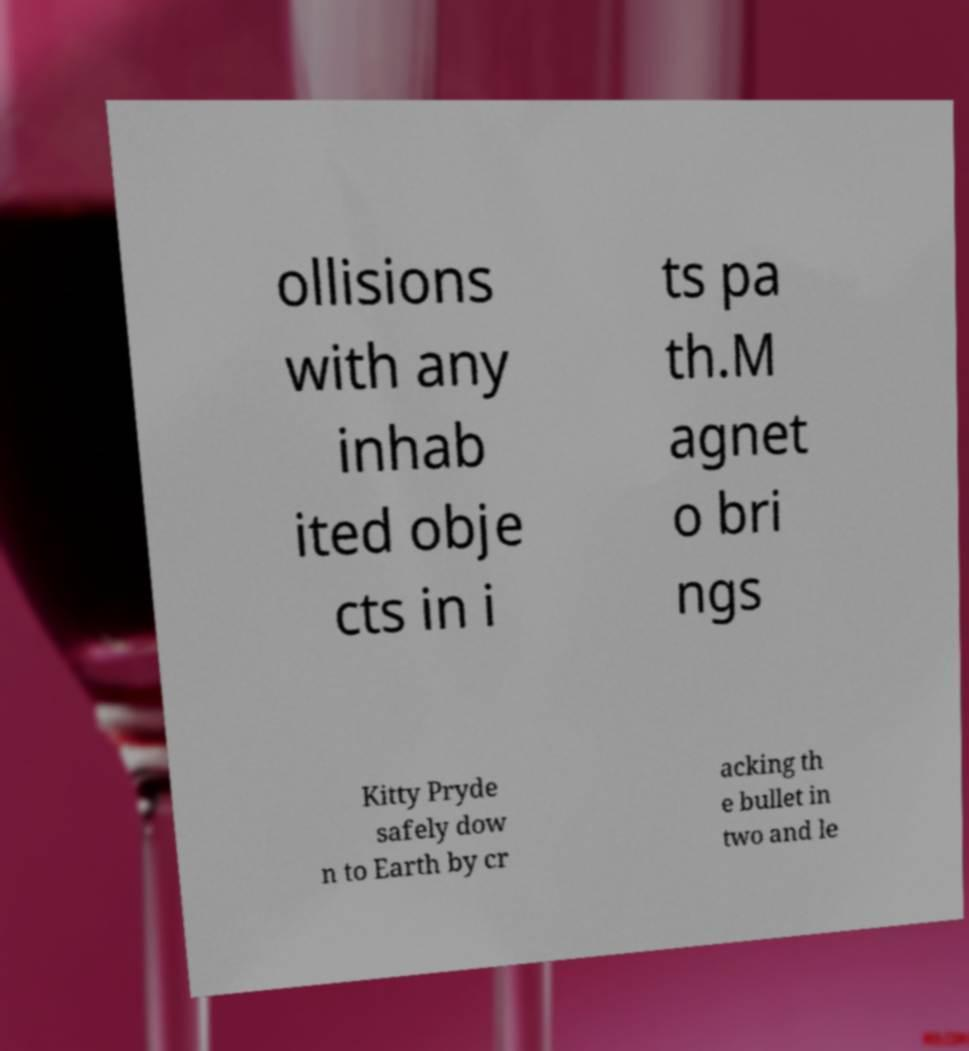Could you extract and type out the text from this image? ollisions with any inhab ited obje cts in i ts pa th.M agnet o bri ngs Kitty Pryde safely dow n to Earth by cr acking th e bullet in two and le 